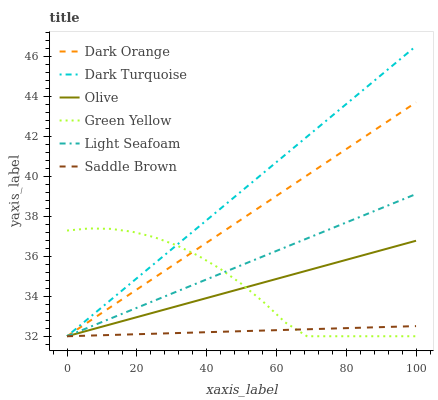Does Light Seafoam have the minimum area under the curve?
Answer yes or no. No. Does Light Seafoam have the maximum area under the curve?
Answer yes or no. No. Is Light Seafoam the smoothest?
Answer yes or no. No. Is Light Seafoam the roughest?
Answer yes or no. No. Does Light Seafoam have the highest value?
Answer yes or no. No. 